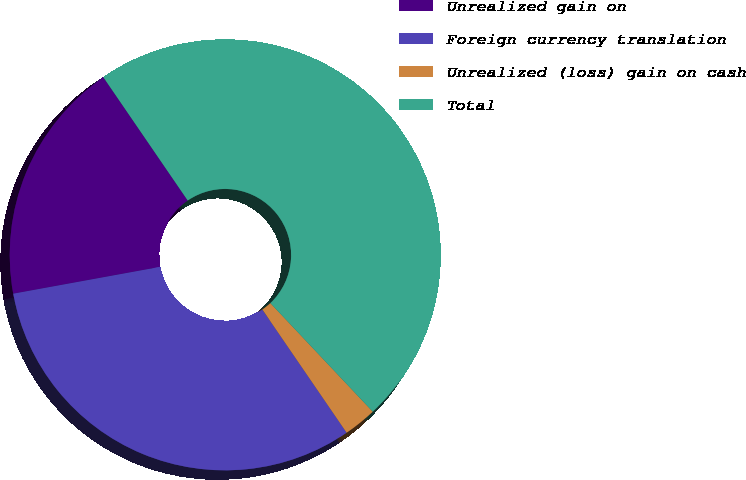Convert chart to OTSL. <chart><loc_0><loc_0><loc_500><loc_500><pie_chart><fcel>Unrealized gain on<fcel>Foreign currency translation<fcel>Unrealized (loss) gain on cash<fcel>Total<nl><fcel>18.32%<fcel>31.68%<fcel>2.48%<fcel>47.52%<nl></chart> 